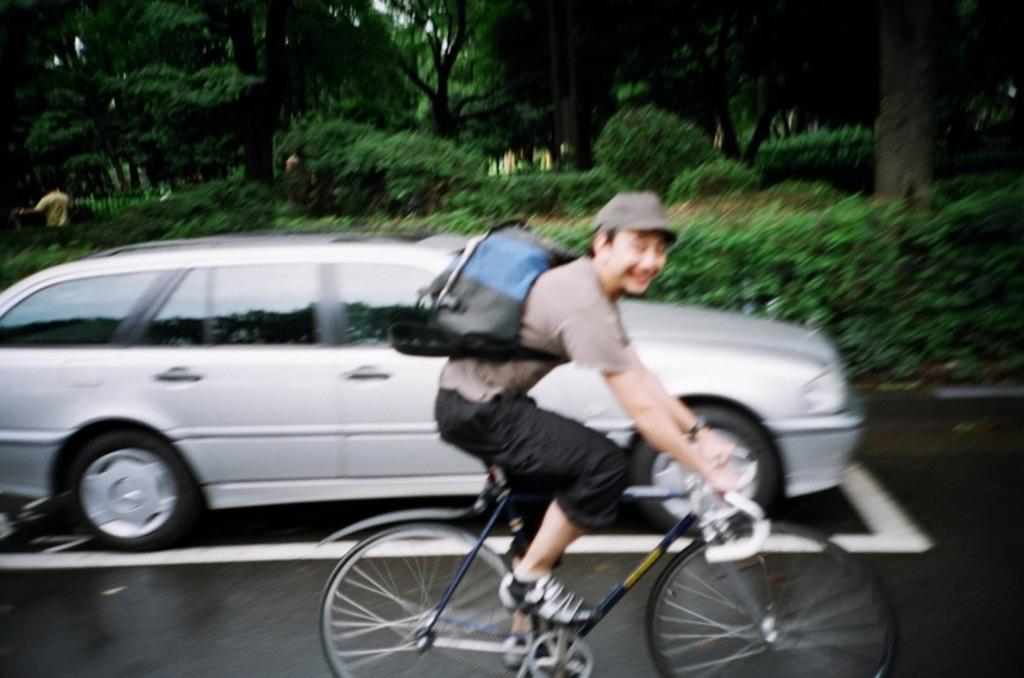Could you give a brief overview of what you see in this image? Here is a man wearing a backpack bag ,a cap and riding bicycle. This is a silver color car. At background I can see a person standing. These are trees and small plants and bushes. 